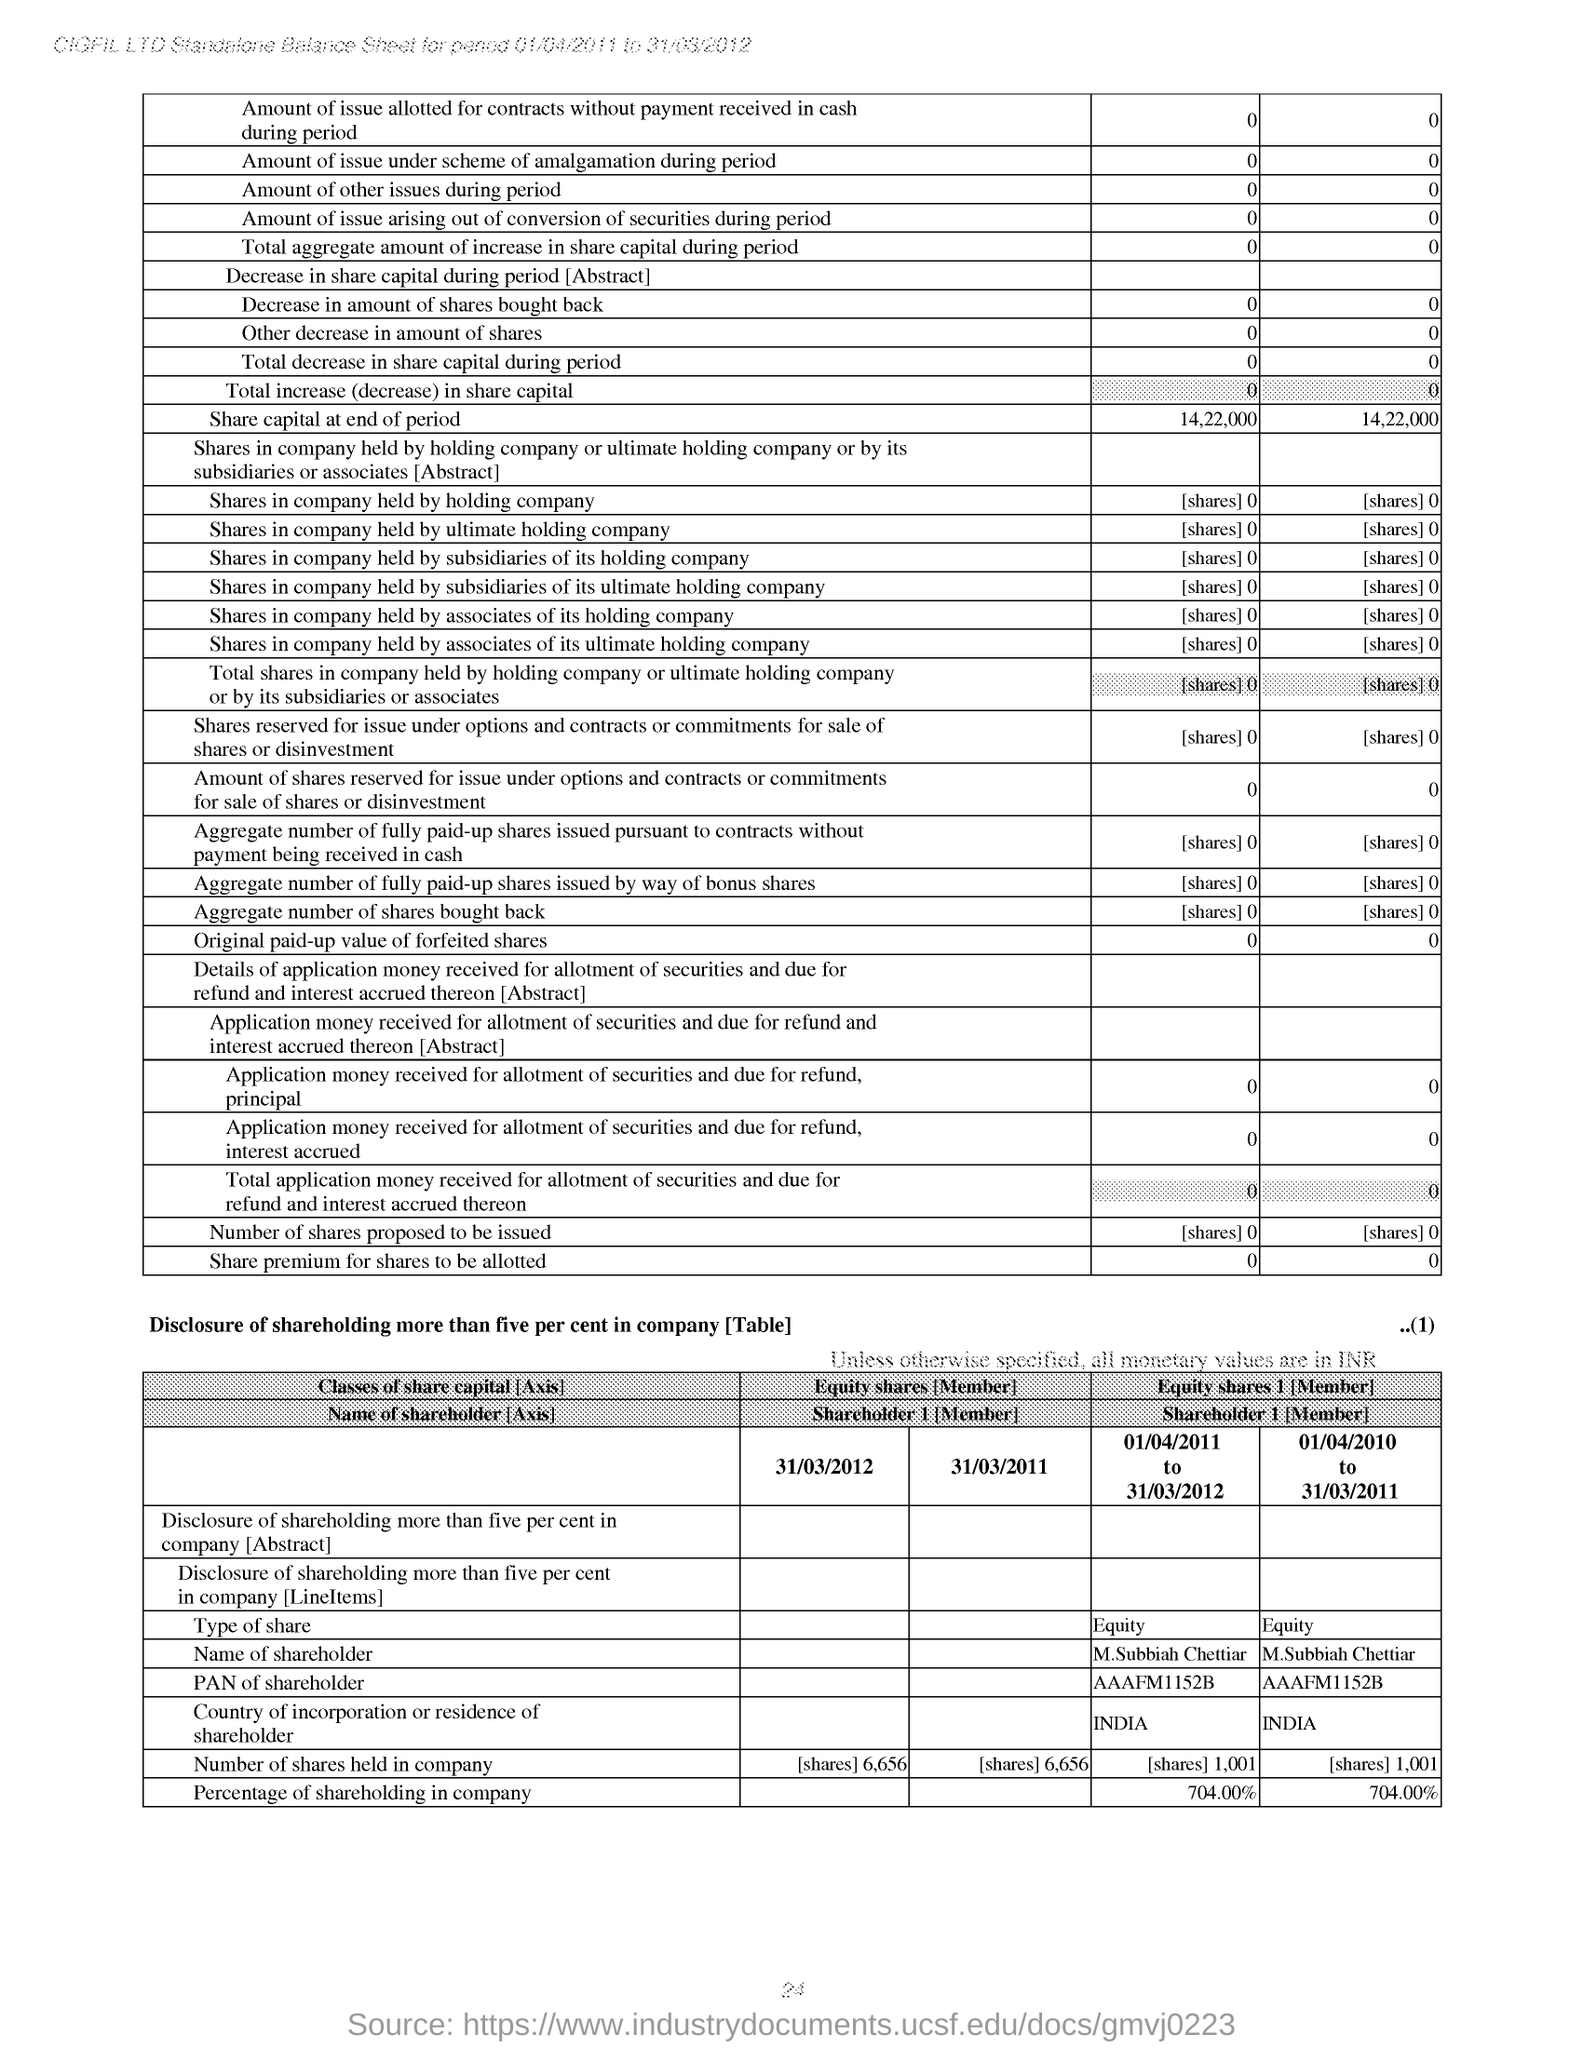Give some essential details in this illustration. The type of share is equity. The share capital at the end of the period was 14,22,000. 